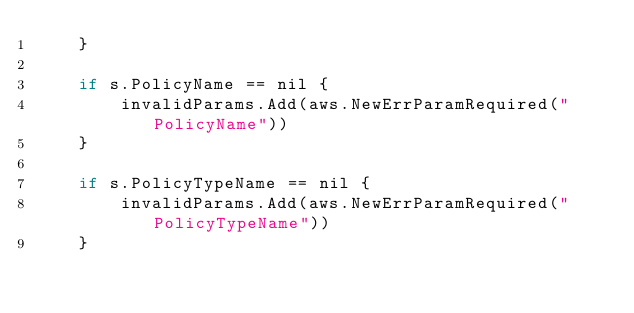<code> <loc_0><loc_0><loc_500><loc_500><_Go_>	}

	if s.PolicyName == nil {
		invalidParams.Add(aws.NewErrParamRequired("PolicyName"))
	}

	if s.PolicyTypeName == nil {
		invalidParams.Add(aws.NewErrParamRequired("PolicyTypeName"))
	}
</code> 